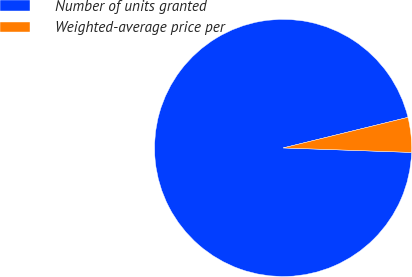<chart> <loc_0><loc_0><loc_500><loc_500><pie_chart><fcel>Number of units granted<fcel>Weighted-average price per<nl><fcel>95.62%<fcel>4.38%<nl></chart> 